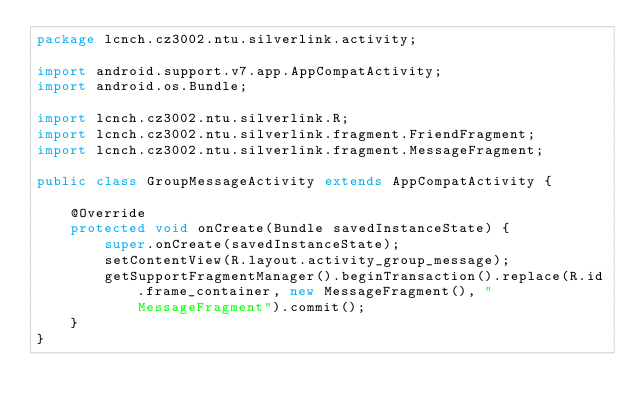Convert code to text. <code><loc_0><loc_0><loc_500><loc_500><_Java_>package lcnch.cz3002.ntu.silverlink.activity;

import android.support.v7.app.AppCompatActivity;
import android.os.Bundle;

import lcnch.cz3002.ntu.silverlink.R;
import lcnch.cz3002.ntu.silverlink.fragment.FriendFragment;
import lcnch.cz3002.ntu.silverlink.fragment.MessageFragment;

public class GroupMessageActivity extends AppCompatActivity {

    @Override
    protected void onCreate(Bundle savedInstanceState) {
        super.onCreate(savedInstanceState);
        setContentView(R.layout.activity_group_message);
        getSupportFragmentManager().beginTransaction().replace(R.id.frame_container, new MessageFragment(), "MessageFragment").commit();
    }
}
</code> 